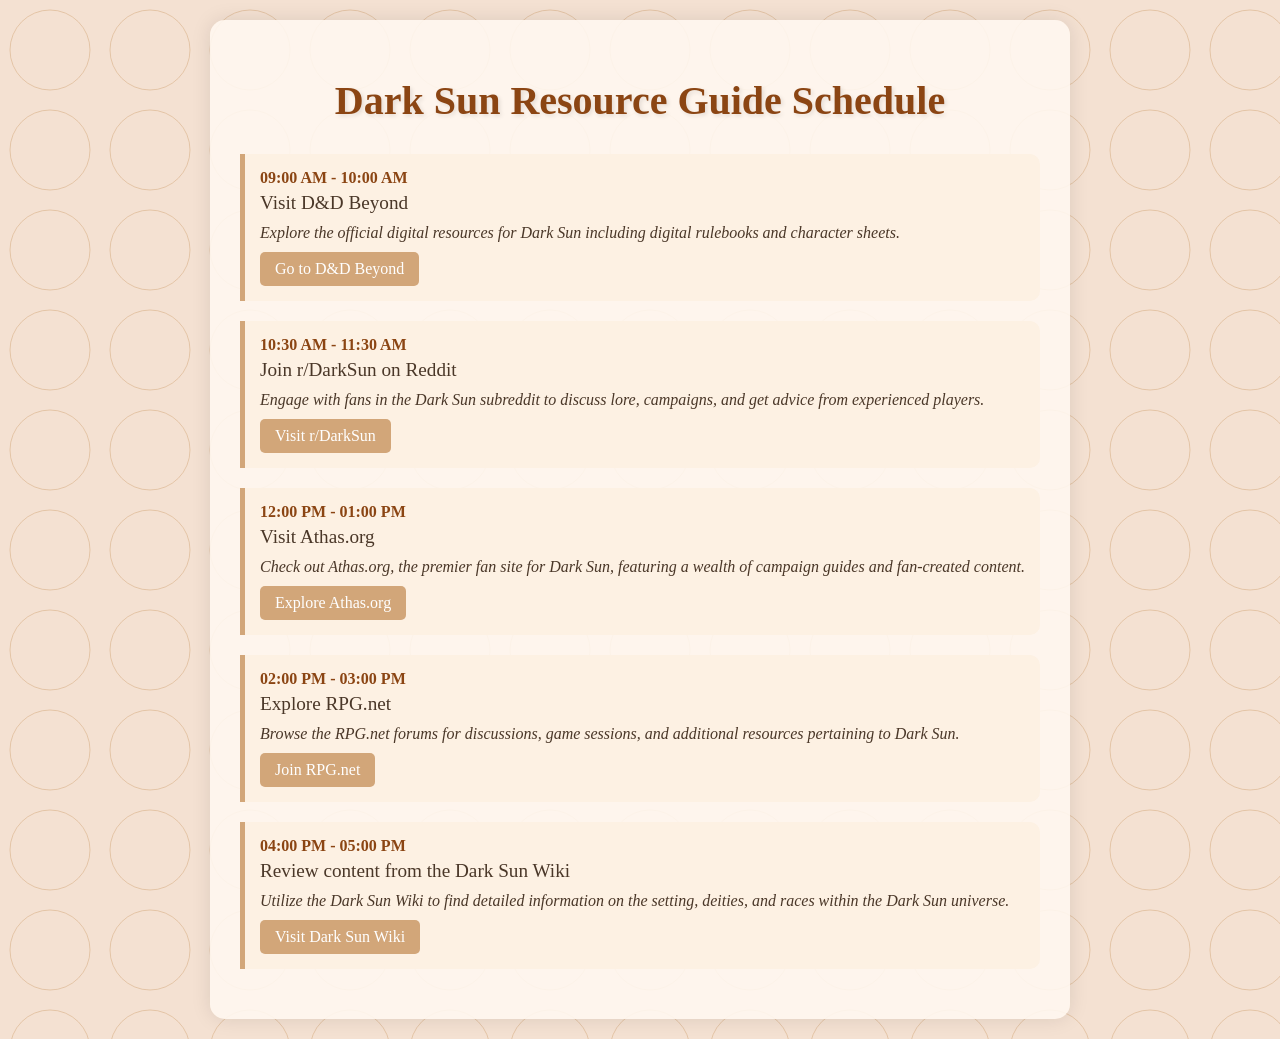What is the first activity listed? The first activity in the schedule is "Visit D&D Beyond," which is the first schedule item mentioned.
Answer: Visit D&D Beyond What time does the second activity start? The second activity, "Join r/DarkSun on Reddit," starts at 10:30 AM according to the scheduled times.
Answer: 10:30 AM How long is each activity scheduled to last? Each activity in the schedule is planned for one hour, as indicated by the time range given for each.
Answer: One hour What website is associated with the third activity? The third activity, "Visit Athas.org," is linked to the website Athas.org for more resources about Dark Sun.
Answer: Athas.org What is the title of the document? The title of the document is prominently displayed at the top and states the purpose of the scheduling.
Answer: Dark Sun Resource Guide Schedule What community platform is mentioned for the fourth activity? The fourth activity refers to RPG.net as the community platform where discussions and resources can be explored.
Answer: RPG.net Which resource provides detailed information about the setting and deities? The Dark Sun Wiki is mentioned as the resource that provides detailed information about the Dark Sun universe.
Answer: Dark Sun Wiki What is the time gap between the second and third activities? There is a one-and-a-half hour gap between the second activity (10:30 AM) and the third activity (12:00 PM).
Answer: One and a half hours 